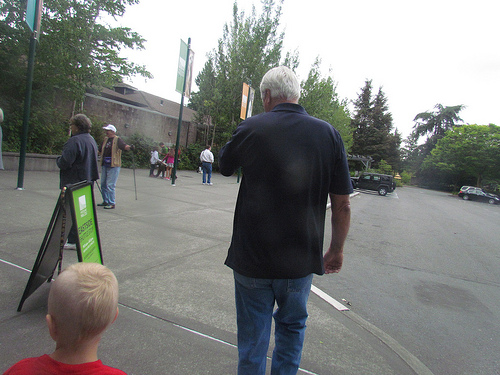<image>
Can you confirm if the man is behind the kid? No. The man is not behind the kid. From this viewpoint, the man appears to be positioned elsewhere in the scene. 